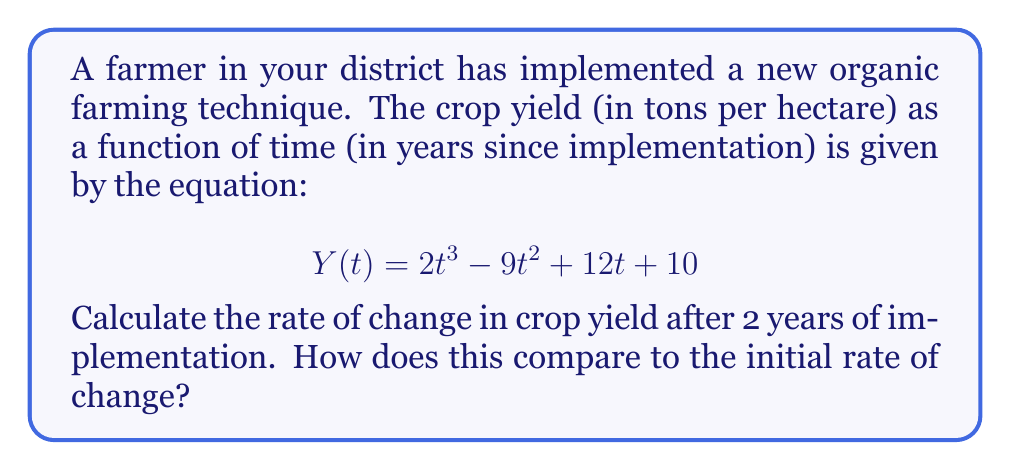Can you answer this question? To solve this problem, we need to use derivatives to find the rate of change in crop yield.

Step 1: Find the derivative of Y(t)
The derivative Y'(t) represents the rate of change of crop yield with respect to time.
$$Y'(t) = \frac{d}{dt}(2t^3 - 9t^2 + 12t + 10)$$
$$Y'(t) = 6t^2 - 18t + 12$$

Step 2: Calculate the rate of change after 2 years
Substitute t = 2 into Y'(t):
$$Y'(2) = 6(2)^2 - 18(2) + 12$$
$$Y'(2) = 24 - 36 + 12 = 0$$

Step 3: Calculate the initial rate of change
The initial rate of change is when t = 0:
$$Y'(0) = 6(0)^2 - 18(0) + 12 = 12$$

Step 4: Compare the two rates
After 2 years, the rate of change is 0 tons per hectare per year, while the initial rate of change was 12 tons per hectare per year.
Answer: 0 tons/hectare/year after 2 years; 12 tons/hectare/year initially 